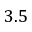<formula> <loc_0><loc_0><loc_500><loc_500>3 . 5</formula> 